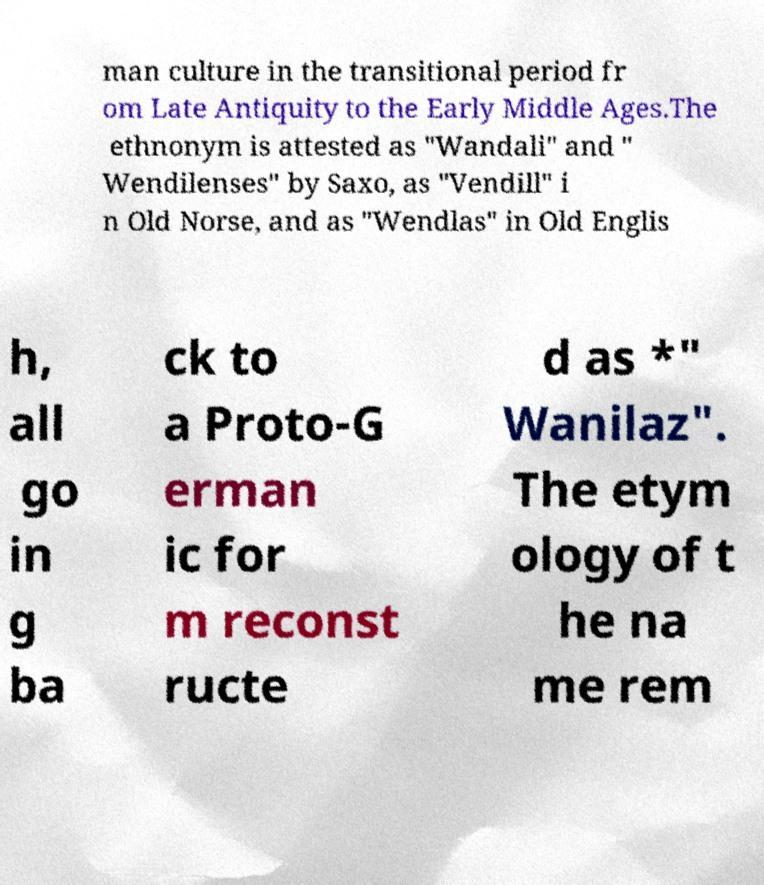What messages or text are displayed in this image? I need them in a readable, typed format. man culture in the transitional period fr om Late Antiquity to the Early Middle Ages.The ethnonym is attested as "Wandali" and " Wendilenses" by Saxo, as "Vendill" i n Old Norse, and as "Wendlas" in Old Englis h, all go in g ba ck to a Proto-G erman ic for m reconst ructe d as *" Wanilaz". The etym ology of t he na me rem 